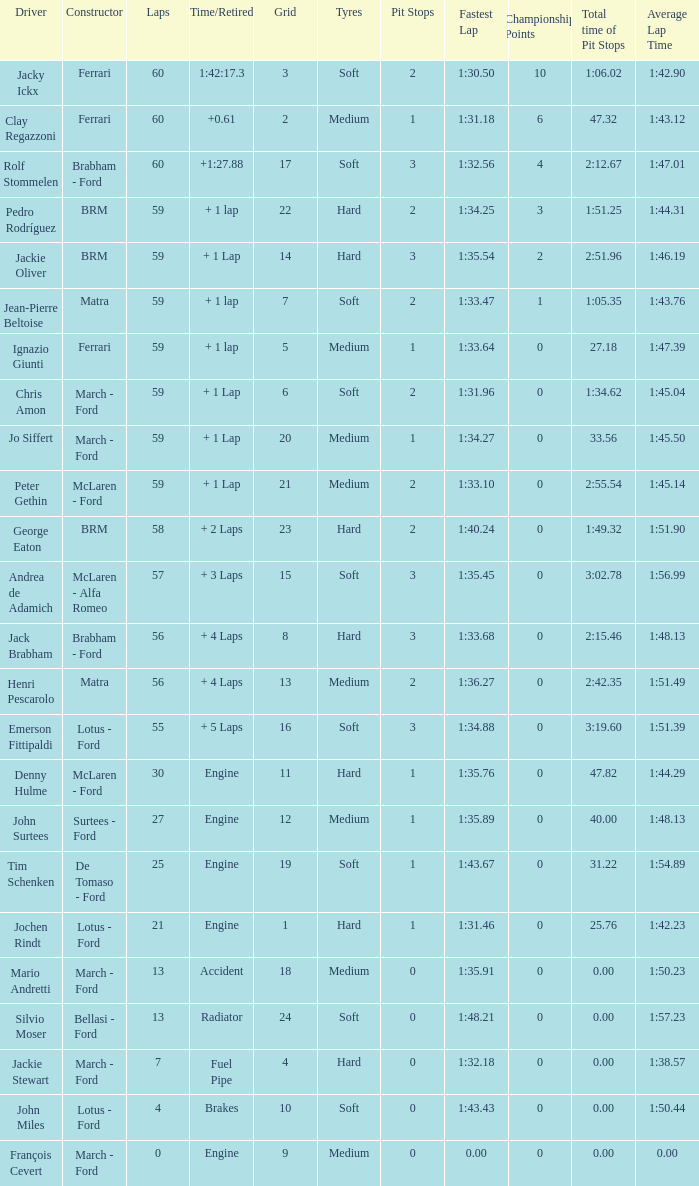I want the driver for grid of 9 François Cevert. 